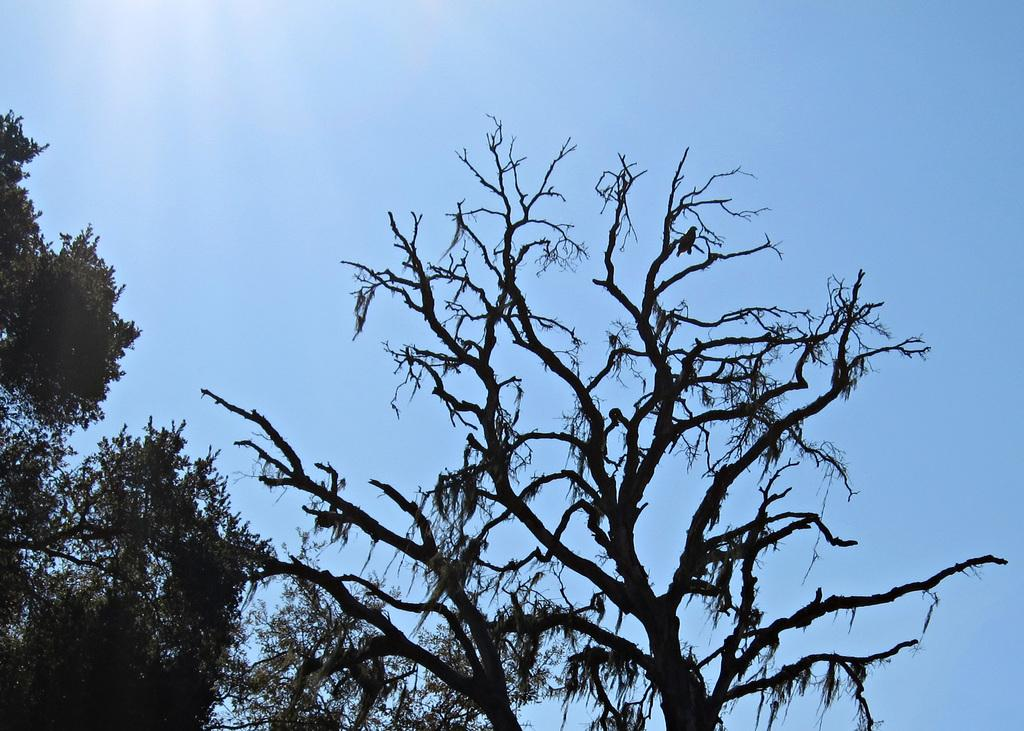What type of vegetation can be seen in the image? There are trees in the image. Can you describe the appearance of the trees? The trees have leaves and branches, and they are likely standing upright. Are there any other objects or structures visible in the image? The provided facts do not mention any other objects or structures. How much does the committee weigh in the image? There is no committee present in the image, so it is not possible to determine its weight. 